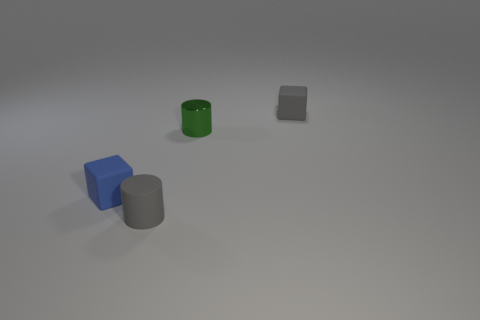How many objects are there in total, and can you describe their shapes and colors? In the image, there are four objects: a green cylinder, a grey cylinder, a blue cube, and a grey matte cube. 
Which object appears to be the largest? The green cylinder seems to be the largest object among the four, given its height and diameter. 